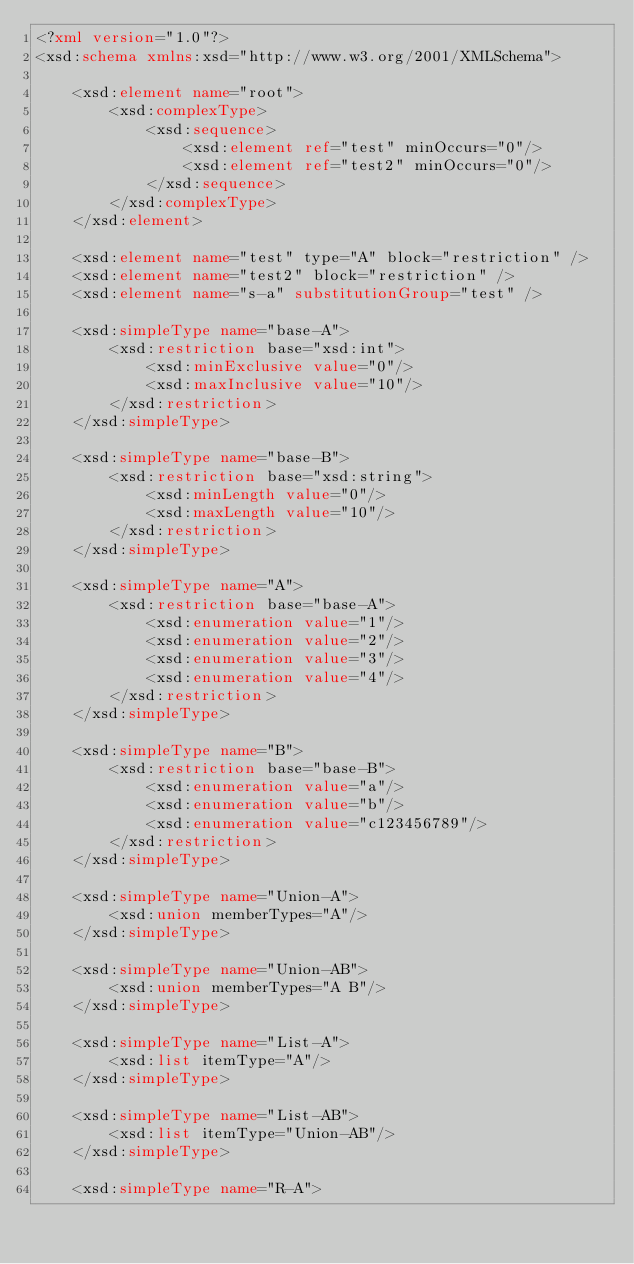<code> <loc_0><loc_0><loc_500><loc_500><_XML_><?xml version="1.0"?>
<xsd:schema xmlns:xsd="http://www.w3.org/2001/XMLSchema">

	<xsd:element name="root">
		<xsd:complexType>
			<xsd:sequence>
				<xsd:element ref="test" minOccurs="0"/>
				<xsd:element ref="test2" minOccurs="0"/>
			</xsd:sequence>
		</xsd:complexType>
	</xsd:element>

	<xsd:element name="test" type="A" block="restriction" />
	<xsd:element name="test2" block="restriction" />
	<xsd:element name="s-a" substitutionGroup="test" />

	<xsd:simpleType name="base-A">
		<xsd:restriction base="xsd:int">
			<xsd:minExclusive value="0"/>
			<xsd:maxInclusive value="10"/>
		</xsd:restriction>
	</xsd:simpleType>

	<xsd:simpleType name="base-B">
		<xsd:restriction base="xsd:string">
			<xsd:minLength value="0"/>
			<xsd:maxLength value="10"/>
		</xsd:restriction>
	</xsd:simpleType>

	<xsd:simpleType name="A">
		<xsd:restriction base="base-A">
			<xsd:enumeration value="1"/>
			<xsd:enumeration value="2"/>
			<xsd:enumeration value="3"/>
			<xsd:enumeration value="4"/>
		</xsd:restriction>
	</xsd:simpleType>

	<xsd:simpleType name="B">
		<xsd:restriction base="base-B">
			<xsd:enumeration value="a"/>
			<xsd:enumeration value="b"/>
			<xsd:enumeration value="c123456789"/>
		</xsd:restriction>
	</xsd:simpleType>

	<xsd:simpleType name="Union-A">
		<xsd:union memberTypes="A"/>
	</xsd:simpleType>

	<xsd:simpleType name="Union-AB">
		<xsd:union memberTypes="A B"/>
	</xsd:simpleType>

	<xsd:simpleType name="List-A">
		<xsd:list itemType="A"/>
	</xsd:simpleType>

	<xsd:simpleType name="List-AB">
		<xsd:list itemType="Union-AB"/>
	</xsd:simpleType>

	<xsd:simpleType name="R-A"></code> 